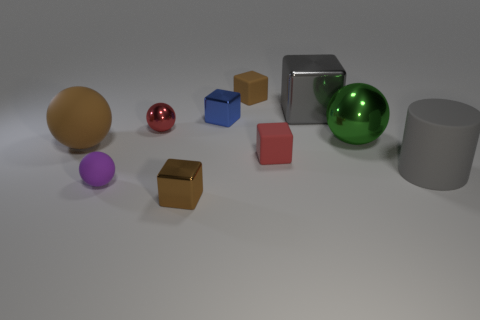How could we use this setup to explain basic principles of geometry? This setup is ideal for teaching geometry principles such as shape recognition, comparing sizes and volumes, understanding three-dimensional forms, and exploring basics of spatial arrangement and perspective. Could you create an example lesson? Certainly! A lesson could involve identifying each object, describing its geometric properties like edges, faces, and vertices, and calculating its volume. Students could compare objects to understand concepts of scaling and proportion, as well as identify symmetries and classify shapes by their properties. 